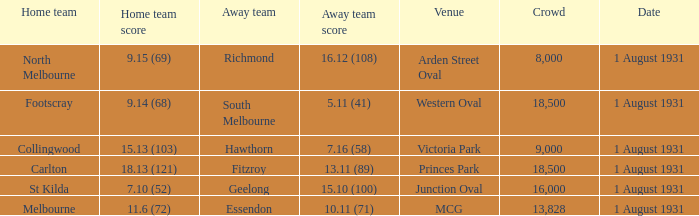What is the home teams score at Victoria Park? 15.13 (103). 